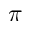Convert formula to latex. <formula><loc_0><loc_0><loc_500><loc_500>\pi</formula> 